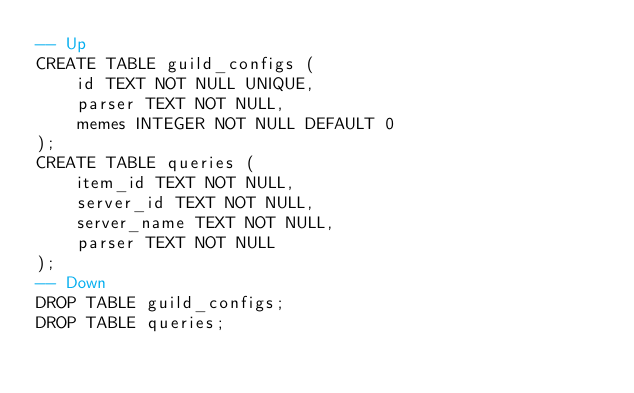<code> <loc_0><loc_0><loc_500><loc_500><_SQL_>-- Up
CREATE TABLE guild_configs (
    id TEXT NOT NULL UNIQUE,
    parser TEXT NOT NULL,
    memes INTEGER NOT NULL DEFAULT 0
);
CREATE TABLE queries (
    item_id TEXT NOT NULL,
    server_id TEXT NOT NULL,
    server_name TEXT NOT NULL,
    parser TEXT NOT NULL
);
-- Down
DROP TABLE guild_configs;
DROP TABLE queries;</code> 